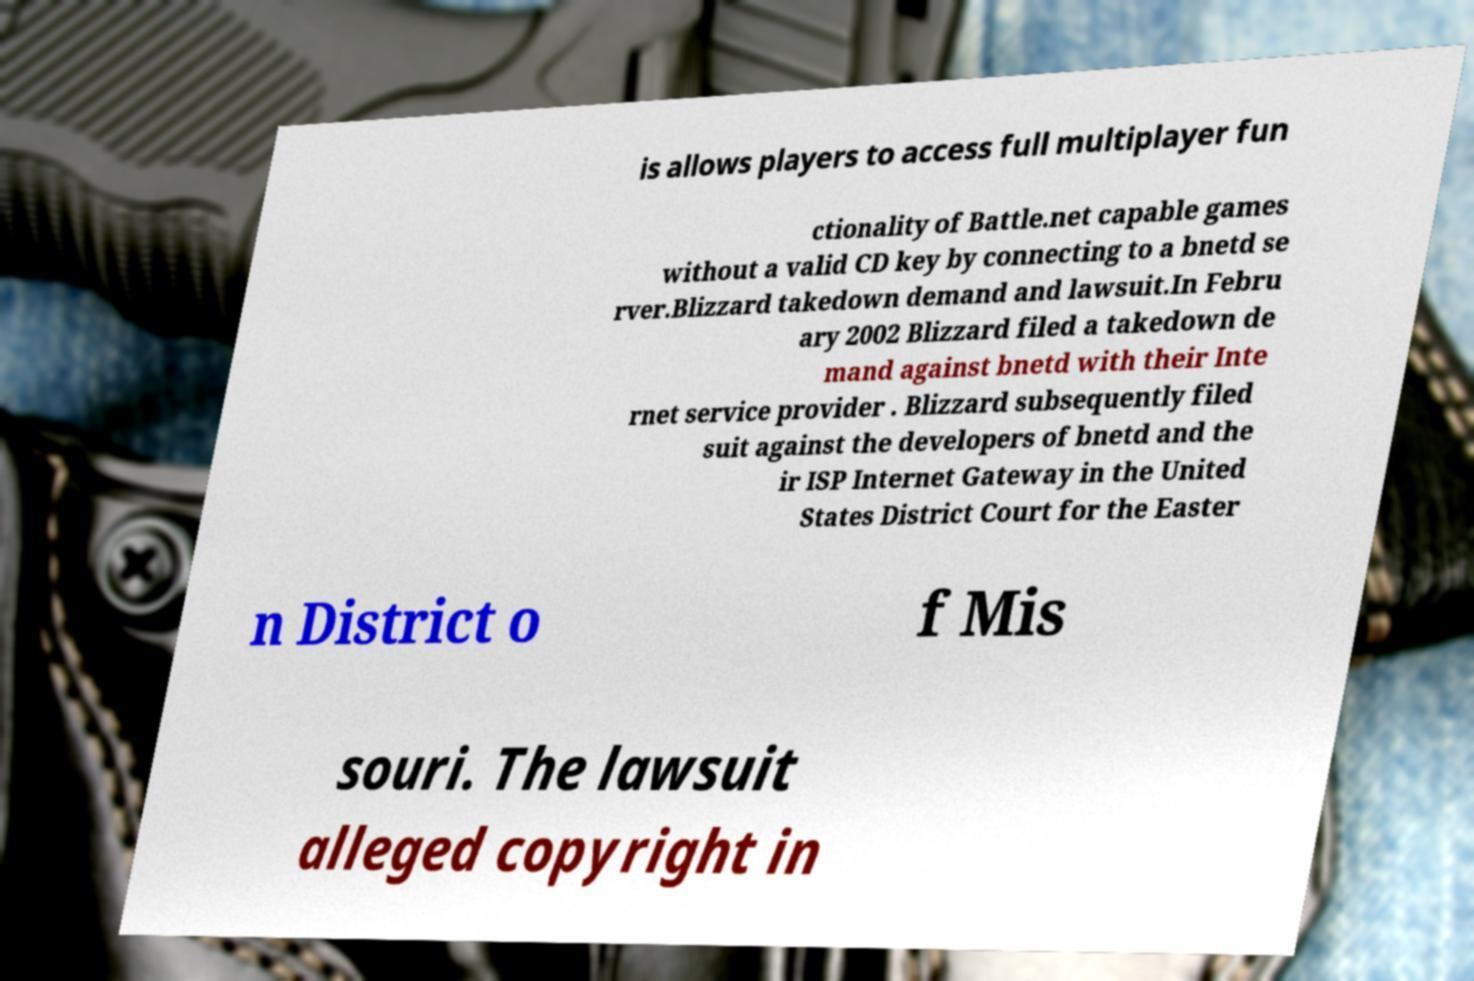Please identify and transcribe the text found in this image. is allows players to access full multiplayer fun ctionality of Battle.net capable games without a valid CD key by connecting to a bnetd se rver.Blizzard takedown demand and lawsuit.In Febru ary 2002 Blizzard filed a takedown de mand against bnetd with their Inte rnet service provider . Blizzard subsequently filed suit against the developers of bnetd and the ir ISP Internet Gateway in the United States District Court for the Easter n District o f Mis souri. The lawsuit alleged copyright in 